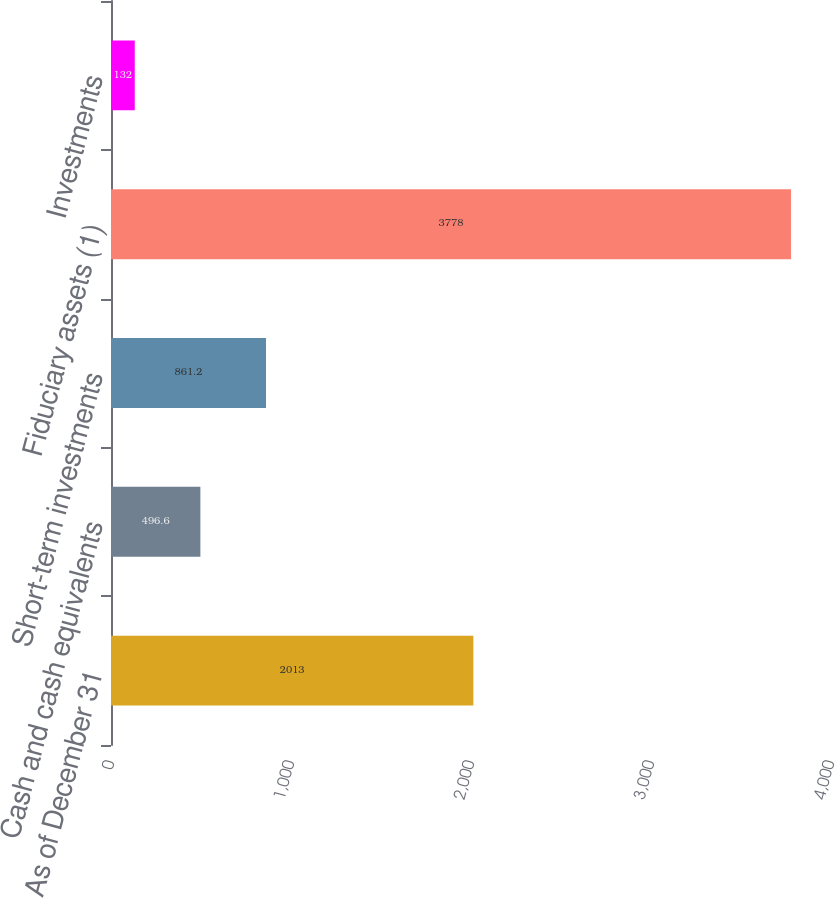Convert chart. <chart><loc_0><loc_0><loc_500><loc_500><bar_chart><fcel>As of December 31<fcel>Cash and cash equivalents<fcel>Short-term investments<fcel>Fiduciary assets (1)<fcel>Investments<nl><fcel>2013<fcel>496.6<fcel>861.2<fcel>3778<fcel>132<nl></chart> 